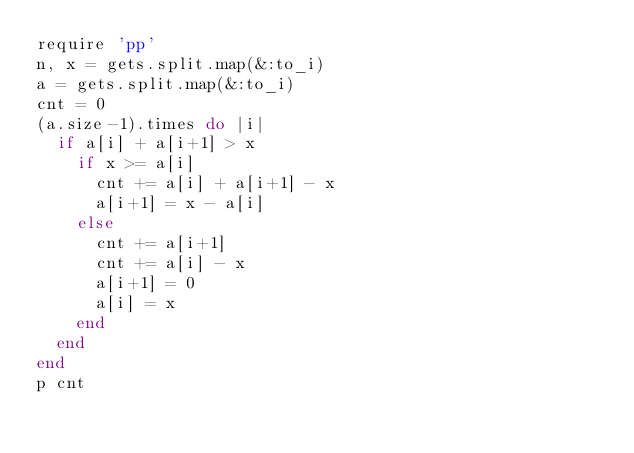<code> <loc_0><loc_0><loc_500><loc_500><_Ruby_>require 'pp'
n, x = gets.split.map(&:to_i)
a = gets.split.map(&:to_i)
cnt = 0
(a.size-1).times do |i|
  if a[i] + a[i+1] > x
    if x >= a[i]
      cnt += a[i] + a[i+1] - x
      a[i+1] = x - a[i]
    else
      cnt += a[i+1]
      cnt += a[i] - x
      a[i+1] = 0
      a[i] = x
    end
  end
end
p cnt
</code> 